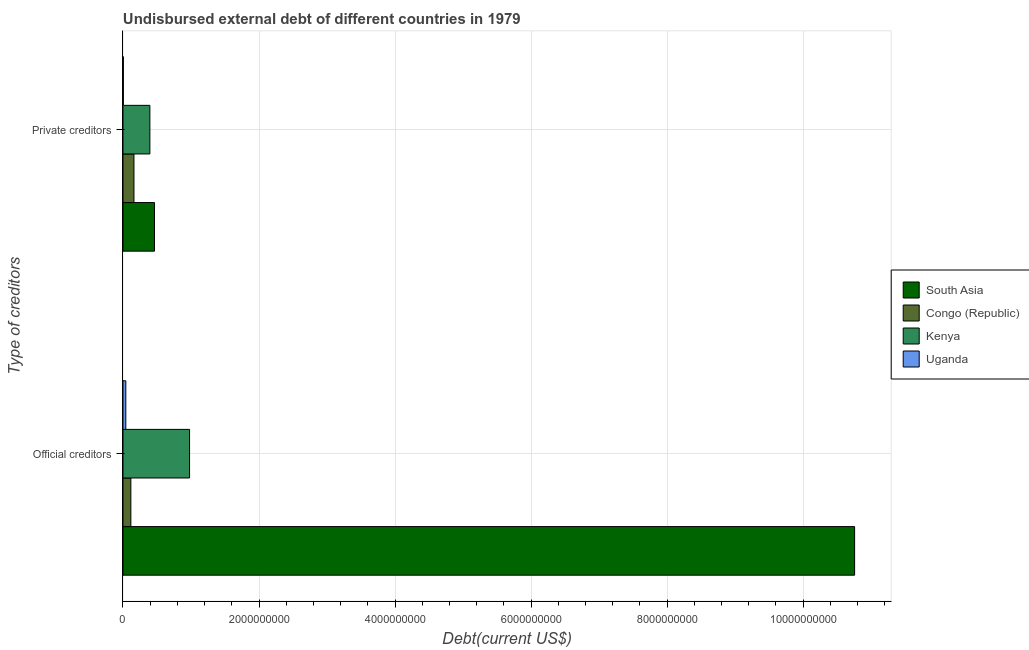How many groups of bars are there?
Ensure brevity in your answer.  2. Are the number of bars per tick equal to the number of legend labels?
Offer a terse response. Yes. How many bars are there on the 1st tick from the bottom?
Your answer should be compact. 4. What is the label of the 1st group of bars from the top?
Provide a succinct answer. Private creditors. What is the undisbursed external debt of official creditors in Uganda?
Your answer should be very brief. 4.16e+07. Across all countries, what is the maximum undisbursed external debt of official creditors?
Provide a succinct answer. 1.08e+1. Across all countries, what is the minimum undisbursed external debt of official creditors?
Offer a terse response. 4.16e+07. In which country was the undisbursed external debt of official creditors maximum?
Give a very brief answer. South Asia. In which country was the undisbursed external debt of official creditors minimum?
Give a very brief answer. Uganda. What is the total undisbursed external debt of official creditors in the graph?
Keep it short and to the point. 1.19e+1. What is the difference between the undisbursed external debt of private creditors in Uganda and that in Congo (Republic)?
Keep it short and to the point. -1.56e+08. What is the difference between the undisbursed external debt of official creditors in Congo (Republic) and the undisbursed external debt of private creditors in Uganda?
Provide a short and direct response. 1.10e+08. What is the average undisbursed external debt of private creditors per country?
Offer a very short reply. 2.56e+08. What is the difference between the undisbursed external debt of private creditors and undisbursed external debt of official creditors in South Asia?
Your response must be concise. -1.03e+1. What is the ratio of the undisbursed external debt of private creditors in South Asia to that in Kenya?
Ensure brevity in your answer.  1.17. What does the 4th bar from the top in Private creditors represents?
Provide a short and direct response. South Asia. What does the 4th bar from the bottom in Private creditors represents?
Your answer should be compact. Uganda. How many bars are there?
Make the answer very short. 8. Are all the bars in the graph horizontal?
Your response must be concise. Yes. Are the values on the major ticks of X-axis written in scientific E-notation?
Offer a terse response. No. How many legend labels are there?
Make the answer very short. 4. How are the legend labels stacked?
Offer a terse response. Vertical. What is the title of the graph?
Offer a very short reply. Undisbursed external debt of different countries in 1979. Does "Saudi Arabia" appear as one of the legend labels in the graph?
Make the answer very short. No. What is the label or title of the X-axis?
Keep it short and to the point. Debt(current US$). What is the label or title of the Y-axis?
Make the answer very short. Type of creditors. What is the Debt(current US$) in South Asia in Official creditors?
Your response must be concise. 1.08e+1. What is the Debt(current US$) of Congo (Republic) in Official creditors?
Offer a very short reply. 1.16e+08. What is the Debt(current US$) of Kenya in Official creditors?
Keep it short and to the point. 9.79e+08. What is the Debt(current US$) in Uganda in Official creditors?
Make the answer very short. 4.16e+07. What is the Debt(current US$) in South Asia in Private creditors?
Provide a short and direct response. 4.63e+08. What is the Debt(current US$) of Congo (Republic) in Private creditors?
Ensure brevity in your answer.  1.61e+08. What is the Debt(current US$) of Kenya in Private creditors?
Your answer should be very brief. 3.95e+08. What is the Debt(current US$) in Uganda in Private creditors?
Offer a very short reply. 5.50e+06. Across all Type of creditors, what is the maximum Debt(current US$) in South Asia?
Your answer should be compact. 1.08e+1. Across all Type of creditors, what is the maximum Debt(current US$) of Congo (Republic)?
Offer a very short reply. 1.61e+08. Across all Type of creditors, what is the maximum Debt(current US$) in Kenya?
Provide a succinct answer. 9.79e+08. Across all Type of creditors, what is the maximum Debt(current US$) of Uganda?
Give a very brief answer. 4.16e+07. Across all Type of creditors, what is the minimum Debt(current US$) of South Asia?
Offer a very short reply. 4.63e+08. Across all Type of creditors, what is the minimum Debt(current US$) in Congo (Republic)?
Ensure brevity in your answer.  1.16e+08. Across all Type of creditors, what is the minimum Debt(current US$) in Kenya?
Your answer should be very brief. 3.95e+08. Across all Type of creditors, what is the minimum Debt(current US$) of Uganda?
Offer a terse response. 5.50e+06. What is the total Debt(current US$) of South Asia in the graph?
Ensure brevity in your answer.  1.12e+1. What is the total Debt(current US$) in Congo (Republic) in the graph?
Offer a very short reply. 2.77e+08. What is the total Debt(current US$) of Kenya in the graph?
Offer a very short reply. 1.37e+09. What is the total Debt(current US$) in Uganda in the graph?
Offer a terse response. 4.71e+07. What is the difference between the Debt(current US$) in South Asia in Official creditors and that in Private creditors?
Your answer should be compact. 1.03e+1. What is the difference between the Debt(current US$) in Congo (Republic) in Official creditors and that in Private creditors?
Provide a succinct answer. -4.55e+07. What is the difference between the Debt(current US$) of Kenya in Official creditors and that in Private creditors?
Keep it short and to the point. 5.83e+08. What is the difference between the Debt(current US$) in Uganda in Official creditors and that in Private creditors?
Make the answer very short. 3.61e+07. What is the difference between the Debt(current US$) in South Asia in Official creditors and the Debt(current US$) in Congo (Republic) in Private creditors?
Your answer should be compact. 1.06e+1. What is the difference between the Debt(current US$) of South Asia in Official creditors and the Debt(current US$) of Kenya in Private creditors?
Provide a succinct answer. 1.04e+1. What is the difference between the Debt(current US$) in South Asia in Official creditors and the Debt(current US$) in Uganda in Private creditors?
Offer a terse response. 1.08e+1. What is the difference between the Debt(current US$) of Congo (Republic) in Official creditors and the Debt(current US$) of Kenya in Private creditors?
Keep it short and to the point. -2.80e+08. What is the difference between the Debt(current US$) in Congo (Republic) in Official creditors and the Debt(current US$) in Uganda in Private creditors?
Make the answer very short. 1.10e+08. What is the difference between the Debt(current US$) in Kenya in Official creditors and the Debt(current US$) in Uganda in Private creditors?
Your response must be concise. 9.73e+08. What is the average Debt(current US$) in South Asia per Type of creditors?
Your answer should be very brief. 5.61e+09. What is the average Debt(current US$) of Congo (Republic) per Type of creditors?
Your answer should be very brief. 1.39e+08. What is the average Debt(current US$) in Kenya per Type of creditors?
Give a very brief answer. 6.87e+08. What is the average Debt(current US$) in Uganda per Type of creditors?
Offer a terse response. 2.36e+07. What is the difference between the Debt(current US$) of South Asia and Debt(current US$) of Congo (Republic) in Official creditors?
Offer a terse response. 1.06e+1. What is the difference between the Debt(current US$) in South Asia and Debt(current US$) in Kenya in Official creditors?
Your response must be concise. 9.78e+09. What is the difference between the Debt(current US$) of South Asia and Debt(current US$) of Uganda in Official creditors?
Your response must be concise. 1.07e+1. What is the difference between the Debt(current US$) of Congo (Republic) and Debt(current US$) of Kenya in Official creditors?
Provide a succinct answer. -8.63e+08. What is the difference between the Debt(current US$) in Congo (Republic) and Debt(current US$) in Uganda in Official creditors?
Ensure brevity in your answer.  7.42e+07. What is the difference between the Debt(current US$) of Kenya and Debt(current US$) of Uganda in Official creditors?
Make the answer very short. 9.37e+08. What is the difference between the Debt(current US$) of South Asia and Debt(current US$) of Congo (Republic) in Private creditors?
Make the answer very short. 3.02e+08. What is the difference between the Debt(current US$) in South Asia and Debt(current US$) in Kenya in Private creditors?
Provide a succinct answer. 6.78e+07. What is the difference between the Debt(current US$) of South Asia and Debt(current US$) of Uganda in Private creditors?
Your answer should be very brief. 4.58e+08. What is the difference between the Debt(current US$) in Congo (Republic) and Debt(current US$) in Kenya in Private creditors?
Ensure brevity in your answer.  -2.34e+08. What is the difference between the Debt(current US$) in Congo (Republic) and Debt(current US$) in Uganda in Private creditors?
Provide a succinct answer. 1.56e+08. What is the difference between the Debt(current US$) in Kenya and Debt(current US$) in Uganda in Private creditors?
Offer a terse response. 3.90e+08. What is the ratio of the Debt(current US$) in South Asia in Official creditors to that in Private creditors?
Offer a very short reply. 23.22. What is the ratio of the Debt(current US$) in Congo (Republic) in Official creditors to that in Private creditors?
Offer a terse response. 0.72. What is the ratio of the Debt(current US$) in Kenya in Official creditors to that in Private creditors?
Your answer should be very brief. 2.48. What is the ratio of the Debt(current US$) of Uganda in Official creditors to that in Private creditors?
Provide a succinct answer. 7.56. What is the difference between the highest and the second highest Debt(current US$) of South Asia?
Make the answer very short. 1.03e+1. What is the difference between the highest and the second highest Debt(current US$) in Congo (Republic)?
Give a very brief answer. 4.55e+07. What is the difference between the highest and the second highest Debt(current US$) of Kenya?
Keep it short and to the point. 5.83e+08. What is the difference between the highest and the second highest Debt(current US$) in Uganda?
Provide a succinct answer. 3.61e+07. What is the difference between the highest and the lowest Debt(current US$) of South Asia?
Your response must be concise. 1.03e+1. What is the difference between the highest and the lowest Debt(current US$) in Congo (Republic)?
Provide a succinct answer. 4.55e+07. What is the difference between the highest and the lowest Debt(current US$) of Kenya?
Ensure brevity in your answer.  5.83e+08. What is the difference between the highest and the lowest Debt(current US$) in Uganda?
Make the answer very short. 3.61e+07. 